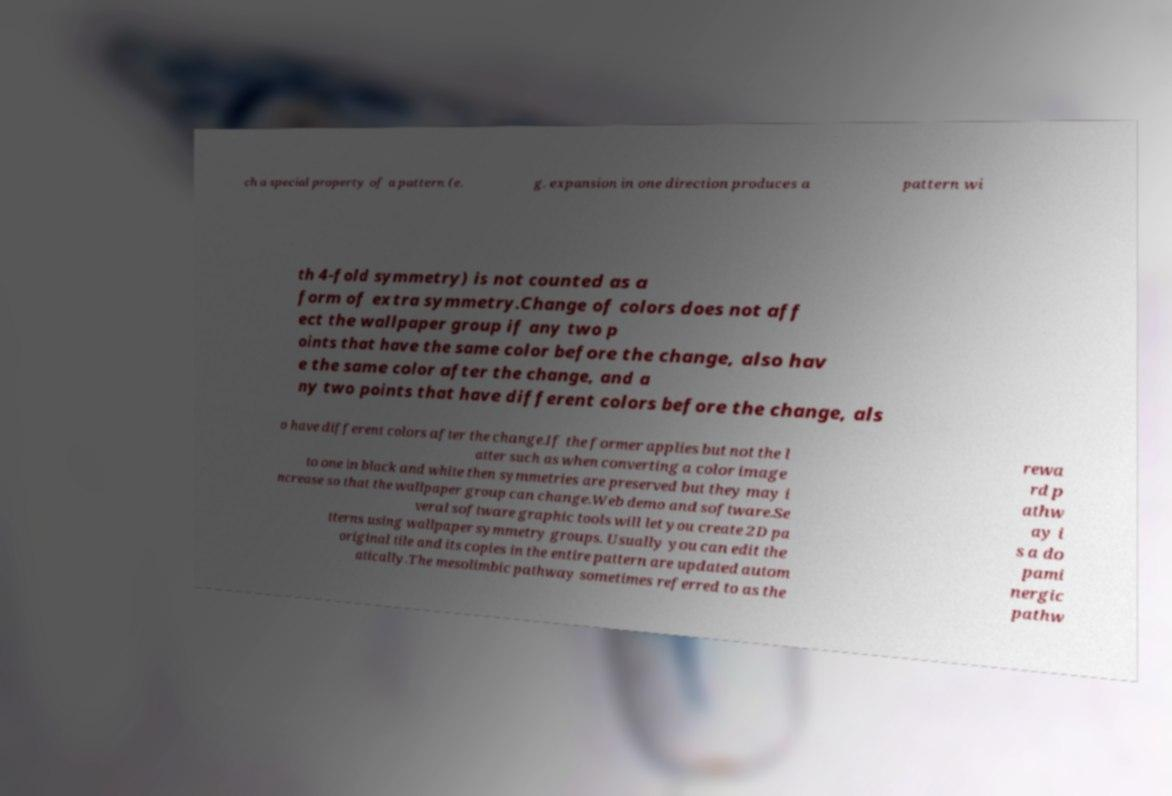Can you read and provide the text displayed in the image?This photo seems to have some interesting text. Can you extract and type it out for me? ch a special property of a pattern (e. g. expansion in one direction produces a pattern wi th 4-fold symmetry) is not counted as a form of extra symmetry.Change of colors does not aff ect the wallpaper group if any two p oints that have the same color before the change, also hav e the same color after the change, and a ny two points that have different colors before the change, als o have different colors after the change.If the former applies but not the l atter such as when converting a color image to one in black and white then symmetries are preserved but they may i ncrease so that the wallpaper group can change.Web demo and software.Se veral software graphic tools will let you create 2D pa tterns using wallpaper symmetry groups. Usually you can edit the original tile and its copies in the entire pattern are updated autom atically.The mesolimbic pathway sometimes referred to as the rewa rd p athw ay i s a do pami nergic pathw 